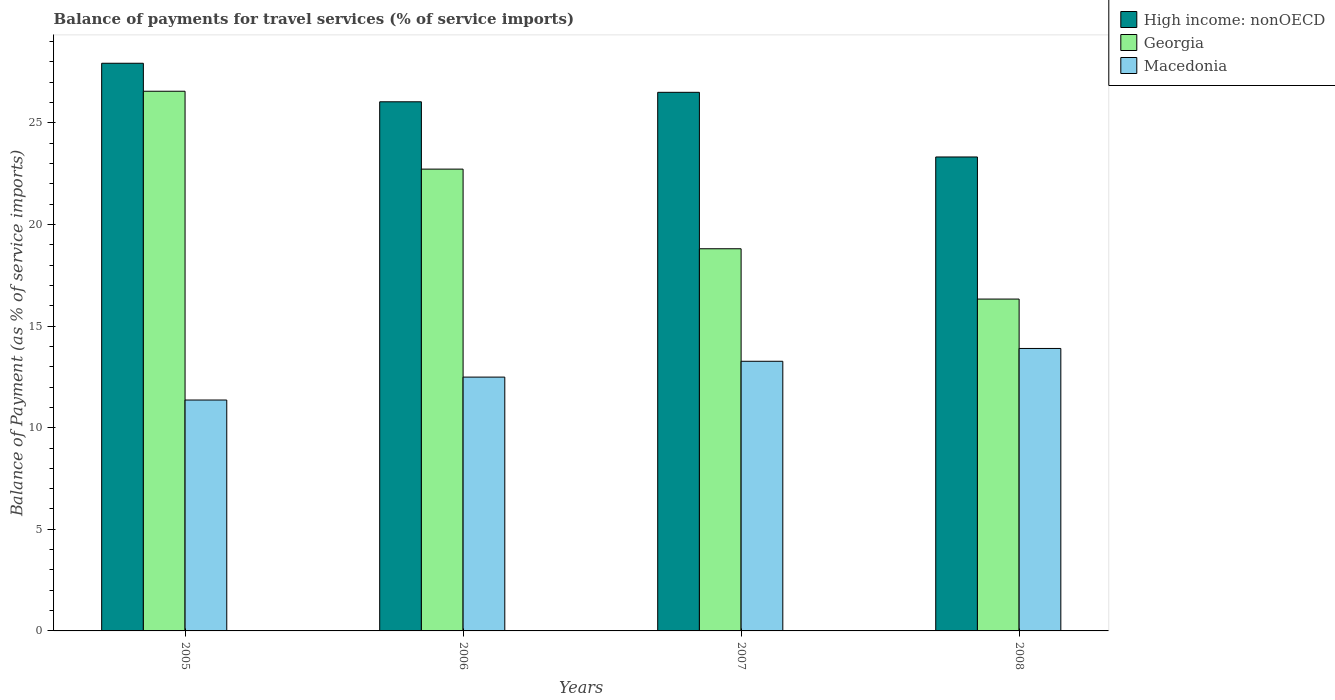How many different coloured bars are there?
Give a very brief answer. 3. How many groups of bars are there?
Give a very brief answer. 4. Are the number of bars on each tick of the X-axis equal?
Give a very brief answer. Yes. What is the label of the 3rd group of bars from the left?
Offer a terse response. 2007. In how many cases, is the number of bars for a given year not equal to the number of legend labels?
Your response must be concise. 0. What is the balance of payments for travel services in High income: nonOECD in 2007?
Offer a terse response. 26.5. Across all years, what is the maximum balance of payments for travel services in Macedonia?
Give a very brief answer. 13.9. Across all years, what is the minimum balance of payments for travel services in Macedonia?
Offer a terse response. 11.36. What is the total balance of payments for travel services in Georgia in the graph?
Your answer should be compact. 84.41. What is the difference between the balance of payments for travel services in Macedonia in 2005 and that in 2008?
Keep it short and to the point. -2.54. What is the difference between the balance of payments for travel services in Macedonia in 2007 and the balance of payments for travel services in Georgia in 2006?
Ensure brevity in your answer.  -9.46. What is the average balance of payments for travel services in High income: nonOECD per year?
Give a very brief answer. 25.95. In the year 2006, what is the difference between the balance of payments for travel services in High income: nonOECD and balance of payments for travel services in Georgia?
Make the answer very short. 3.31. What is the ratio of the balance of payments for travel services in Macedonia in 2006 to that in 2007?
Your response must be concise. 0.94. Is the balance of payments for travel services in High income: nonOECD in 2006 less than that in 2008?
Provide a short and direct response. No. What is the difference between the highest and the second highest balance of payments for travel services in Macedonia?
Your answer should be compact. 0.63. What is the difference between the highest and the lowest balance of payments for travel services in Macedonia?
Give a very brief answer. 2.54. Is the sum of the balance of payments for travel services in Georgia in 2007 and 2008 greater than the maximum balance of payments for travel services in Macedonia across all years?
Give a very brief answer. Yes. What does the 1st bar from the left in 2005 represents?
Offer a very short reply. High income: nonOECD. What does the 1st bar from the right in 2007 represents?
Offer a terse response. Macedonia. Are all the bars in the graph horizontal?
Keep it short and to the point. No. How many years are there in the graph?
Provide a short and direct response. 4. What is the difference between two consecutive major ticks on the Y-axis?
Provide a short and direct response. 5. Are the values on the major ticks of Y-axis written in scientific E-notation?
Your response must be concise. No. Does the graph contain any zero values?
Give a very brief answer. No. Where does the legend appear in the graph?
Your answer should be compact. Top right. How many legend labels are there?
Provide a succinct answer. 3. How are the legend labels stacked?
Provide a short and direct response. Vertical. What is the title of the graph?
Your answer should be compact. Balance of payments for travel services (% of service imports). What is the label or title of the X-axis?
Your answer should be compact. Years. What is the label or title of the Y-axis?
Ensure brevity in your answer.  Balance of Payment (as % of service imports). What is the Balance of Payment (as % of service imports) in High income: nonOECD in 2005?
Provide a short and direct response. 27.93. What is the Balance of Payment (as % of service imports) of Georgia in 2005?
Offer a terse response. 26.56. What is the Balance of Payment (as % of service imports) of Macedonia in 2005?
Provide a short and direct response. 11.36. What is the Balance of Payment (as % of service imports) in High income: nonOECD in 2006?
Your answer should be compact. 26.04. What is the Balance of Payment (as % of service imports) in Georgia in 2006?
Offer a very short reply. 22.72. What is the Balance of Payment (as % of service imports) of Macedonia in 2006?
Keep it short and to the point. 12.49. What is the Balance of Payment (as % of service imports) in High income: nonOECD in 2007?
Provide a short and direct response. 26.5. What is the Balance of Payment (as % of service imports) in Georgia in 2007?
Your answer should be compact. 18.8. What is the Balance of Payment (as % of service imports) in Macedonia in 2007?
Provide a short and direct response. 13.27. What is the Balance of Payment (as % of service imports) of High income: nonOECD in 2008?
Make the answer very short. 23.32. What is the Balance of Payment (as % of service imports) in Georgia in 2008?
Keep it short and to the point. 16.33. What is the Balance of Payment (as % of service imports) in Macedonia in 2008?
Your answer should be compact. 13.9. Across all years, what is the maximum Balance of Payment (as % of service imports) of High income: nonOECD?
Give a very brief answer. 27.93. Across all years, what is the maximum Balance of Payment (as % of service imports) of Georgia?
Provide a succinct answer. 26.56. Across all years, what is the maximum Balance of Payment (as % of service imports) in Macedonia?
Give a very brief answer. 13.9. Across all years, what is the minimum Balance of Payment (as % of service imports) of High income: nonOECD?
Your answer should be compact. 23.32. Across all years, what is the minimum Balance of Payment (as % of service imports) of Georgia?
Keep it short and to the point. 16.33. Across all years, what is the minimum Balance of Payment (as % of service imports) in Macedonia?
Provide a succinct answer. 11.36. What is the total Balance of Payment (as % of service imports) in High income: nonOECD in the graph?
Provide a short and direct response. 103.79. What is the total Balance of Payment (as % of service imports) of Georgia in the graph?
Your response must be concise. 84.41. What is the total Balance of Payment (as % of service imports) of Macedonia in the graph?
Your answer should be compact. 51.02. What is the difference between the Balance of Payment (as % of service imports) in High income: nonOECD in 2005 and that in 2006?
Provide a succinct answer. 1.9. What is the difference between the Balance of Payment (as % of service imports) in Georgia in 2005 and that in 2006?
Give a very brief answer. 3.83. What is the difference between the Balance of Payment (as % of service imports) of Macedonia in 2005 and that in 2006?
Ensure brevity in your answer.  -1.13. What is the difference between the Balance of Payment (as % of service imports) in High income: nonOECD in 2005 and that in 2007?
Your response must be concise. 1.43. What is the difference between the Balance of Payment (as % of service imports) in Georgia in 2005 and that in 2007?
Ensure brevity in your answer.  7.75. What is the difference between the Balance of Payment (as % of service imports) of Macedonia in 2005 and that in 2007?
Your answer should be compact. -1.91. What is the difference between the Balance of Payment (as % of service imports) of High income: nonOECD in 2005 and that in 2008?
Keep it short and to the point. 4.61. What is the difference between the Balance of Payment (as % of service imports) in Georgia in 2005 and that in 2008?
Keep it short and to the point. 10.23. What is the difference between the Balance of Payment (as % of service imports) in Macedonia in 2005 and that in 2008?
Ensure brevity in your answer.  -2.54. What is the difference between the Balance of Payment (as % of service imports) in High income: nonOECD in 2006 and that in 2007?
Make the answer very short. -0.47. What is the difference between the Balance of Payment (as % of service imports) of Georgia in 2006 and that in 2007?
Your answer should be very brief. 3.92. What is the difference between the Balance of Payment (as % of service imports) of Macedonia in 2006 and that in 2007?
Your response must be concise. -0.78. What is the difference between the Balance of Payment (as % of service imports) of High income: nonOECD in 2006 and that in 2008?
Provide a short and direct response. 2.72. What is the difference between the Balance of Payment (as % of service imports) of Georgia in 2006 and that in 2008?
Make the answer very short. 6.4. What is the difference between the Balance of Payment (as % of service imports) of Macedonia in 2006 and that in 2008?
Your response must be concise. -1.41. What is the difference between the Balance of Payment (as % of service imports) of High income: nonOECD in 2007 and that in 2008?
Keep it short and to the point. 3.18. What is the difference between the Balance of Payment (as % of service imports) of Georgia in 2007 and that in 2008?
Provide a succinct answer. 2.48. What is the difference between the Balance of Payment (as % of service imports) in Macedonia in 2007 and that in 2008?
Make the answer very short. -0.63. What is the difference between the Balance of Payment (as % of service imports) of High income: nonOECD in 2005 and the Balance of Payment (as % of service imports) of Georgia in 2006?
Make the answer very short. 5.21. What is the difference between the Balance of Payment (as % of service imports) of High income: nonOECD in 2005 and the Balance of Payment (as % of service imports) of Macedonia in 2006?
Give a very brief answer. 15.44. What is the difference between the Balance of Payment (as % of service imports) in Georgia in 2005 and the Balance of Payment (as % of service imports) in Macedonia in 2006?
Provide a short and direct response. 14.07. What is the difference between the Balance of Payment (as % of service imports) in High income: nonOECD in 2005 and the Balance of Payment (as % of service imports) in Georgia in 2007?
Ensure brevity in your answer.  9.13. What is the difference between the Balance of Payment (as % of service imports) in High income: nonOECD in 2005 and the Balance of Payment (as % of service imports) in Macedonia in 2007?
Ensure brevity in your answer.  14.66. What is the difference between the Balance of Payment (as % of service imports) in Georgia in 2005 and the Balance of Payment (as % of service imports) in Macedonia in 2007?
Offer a very short reply. 13.29. What is the difference between the Balance of Payment (as % of service imports) in High income: nonOECD in 2005 and the Balance of Payment (as % of service imports) in Georgia in 2008?
Offer a very short reply. 11.6. What is the difference between the Balance of Payment (as % of service imports) of High income: nonOECD in 2005 and the Balance of Payment (as % of service imports) of Macedonia in 2008?
Offer a very short reply. 14.03. What is the difference between the Balance of Payment (as % of service imports) in Georgia in 2005 and the Balance of Payment (as % of service imports) in Macedonia in 2008?
Give a very brief answer. 12.66. What is the difference between the Balance of Payment (as % of service imports) of High income: nonOECD in 2006 and the Balance of Payment (as % of service imports) of Georgia in 2007?
Your answer should be compact. 7.23. What is the difference between the Balance of Payment (as % of service imports) of High income: nonOECD in 2006 and the Balance of Payment (as % of service imports) of Macedonia in 2007?
Provide a succinct answer. 12.77. What is the difference between the Balance of Payment (as % of service imports) of Georgia in 2006 and the Balance of Payment (as % of service imports) of Macedonia in 2007?
Provide a short and direct response. 9.46. What is the difference between the Balance of Payment (as % of service imports) in High income: nonOECD in 2006 and the Balance of Payment (as % of service imports) in Georgia in 2008?
Your answer should be compact. 9.71. What is the difference between the Balance of Payment (as % of service imports) in High income: nonOECD in 2006 and the Balance of Payment (as % of service imports) in Macedonia in 2008?
Offer a very short reply. 12.14. What is the difference between the Balance of Payment (as % of service imports) in Georgia in 2006 and the Balance of Payment (as % of service imports) in Macedonia in 2008?
Keep it short and to the point. 8.82. What is the difference between the Balance of Payment (as % of service imports) in High income: nonOECD in 2007 and the Balance of Payment (as % of service imports) in Georgia in 2008?
Make the answer very short. 10.17. What is the difference between the Balance of Payment (as % of service imports) in High income: nonOECD in 2007 and the Balance of Payment (as % of service imports) in Macedonia in 2008?
Give a very brief answer. 12.6. What is the difference between the Balance of Payment (as % of service imports) of Georgia in 2007 and the Balance of Payment (as % of service imports) of Macedonia in 2008?
Offer a very short reply. 4.91. What is the average Balance of Payment (as % of service imports) of High income: nonOECD per year?
Make the answer very short. 25.95. What is the average Balance of Payment (as % of service imports) of Georgia per year?
Provide a short and direct response. 21.1. What is the average Balance of Payment (as % of service imports) of Macedonia per year?
Keep it short and to the point. 12.75. In the year 2005, what is the difference between the Balance of Payment (as % of service imports) of High income: nonOECD and Balance of Payment (as % of service imports) of Georgia?
Give a very brief answer. 1.38. In the year 2005, what is the difference between the Balance of Payment (as % of service imports) of High income: nonOECD and Balance of Payment (as % of service imports) of Macedonia?
Keep it short and to the point. 16.57. In the year 2005, what is the difference between the Balance of Payment (as % of service imports) in Georgia and Balance of Payment (as % of service imports) in Macedonia?
Provide a short and direct response. 15.19. In the year 2006, what is the difference between the Balance of Payment (as % of service imports) of High income: nonOECD and Balance of Payment (as % of service imports) of Georgia?
Give a very brief answer. 3.31. In the year 2006, what is the difference between the Balance of Payment (as % of service imports) in High income: nonOECD and Balance of Payment (as % of service imports) in Macedonia?
Offer a terse response. 13.55. In the year 2006, what is the difference between the Balance of Payment (as % of service imports) in Georgia and Balance of Payment (as % of service imports) in Macedonia?
Keep it short and to the point. 10.23. In the year 2007, what is the difference between the Balance of Payment (as % of service imports) in High income: nonOECD and Balance of Payment (as % of service imports) in Georgia?
Provide a succinct answer. 7.7. In the year 2007, what is the difference between the Balance of Payment (as % of service imports) of High income: nonOECD and Balance of Payment (as % of service imports) of Macedonia?
Make the answer very short. 13.23. In the year 2007, what is the difference between the Balance of Payment (as % of service imports) of Georgia and Balance of Payment (as % of service imports) of Macedonia?
Your answer should be compact. 5.54. In the year 2008, what is the difference between the Balance of Payment (as % of service imports) of High income: nonOECD and Balance of Payment (as % of service imports) of Georgia?
Offer a terse response. 6.99. In the year 2008, what is the difference between the Balance of Payment (as % of service imports) of High income: nonOECD and Balance of Payment (as % of service imports) of Macedonia?
Your answer should be very brief. 9.42. In the year 2008, what is the difference between the Balance of Payment (as % of service imports) in Georgia and Balance of Payment (as % of service imports) in Macedonia?
Provide a succinct answer. 2.43. What is the ratio of the Balance of Payment (as % of service imports) in High income: nonOECD in 2005 to that in 2006?
Your answer should be compact. 1.07. What is the ratio of the Balance of Payment (as % of service imports) of Georgia in 2005 to that in 2006?
Provide a short and direct response. 1.17. What is the ratio of the Balance of Payment (as % of service imports) of Macedonia in 2005 to that in 2006?
Offer a terse response. 0.91. What is the ratio of the Balance of Payment (as % of service imports) in High income: nonOECD in 2005 to that in 2007?
Your answer should be compact. 1.05. What is the ratio of the Balance of Payment (as % of service imports) in Georgia in 2005 to that in 2007?
Provide a succinct answer. 1.41. What is the ratio of the Balance of Payment (as % of service imports) of Macedonia in 2005 to that in 2007?
Your response must be concise. 0.86. What is the ratio of the Balance of Payment (as % of service imports) of High income: nonOECD in 2005 to that in 2008?
Your answer should be compact. 1.2. What is the ratio of the Balance of Payment (as % of service imports) in Georgia in 2005 to that in 2008?
Your response must be concise. 1.63. What is the ratio of the Balance of Payment (as % of service imports) of Macedonia in 2005 to that in 2008?
Your response must be concise. 0.82. What is the ratio of the Balance of Payment (as % of service imports) in High income: nonOECD in 2006 to that in 2007?
Provide a short and direct response. 0.98. What is the ratio of the Balance of Payment (as % of service imports) of Georgia in 2006 to that in 2007?
Ensure brevity in your answer.  1.21. What is the ratio of the Balance of Payment (as % of service imports) in Macedonia in 2006 to that in 2007?
Offer a terse response. 0.94. What is the ratio of the Balance of Payment (as % of service imports) of High income: nonOECD in 2006 to that in 2008?
Offer a very short reply. 1.12. What is the ratio of the Balance of Payment (as % of service imports) of Georgia in 2006 to that in 2008?
Offer a terse response. 1.39. What is the ratio of the Balance of Payment (as % of service imports) in Macedonia in 2006 to that in 2008?
Offer a terse response. 0.9. What is the ratio of the Balance of Payment (as % of service imports) of High income: nonOECD in 2007 to that in 2008?
Make the answer very short. 1.14. What is the ratio of the Balance of Payment (as % of service imports) in Georgia in 2007 to that in 2008?
Keep it short and to the point. 1.15. What is the ratio of the Balance of Payment (as % of service imports) in Macedonia in 2007 to that in 2008?
Offer a terse response. 0.95. What is the difference between the highest and the second highest Balance of Payment (as % of service imports) in High income: nonOECD?
Your answer should be very brief. 1.43. What is the difference between the highest and the second highest Balance of Payment (as % of service imports) of Georgia?
Give a very brief answer. 3.83. What is the difference between the highest and the second highest Balance of Payment (as % of service imports) of Macedonia?
Give a very brief answer. 0.63. What is the difference between the highest and the lowest Balance of Payment (as % of service imports) in High income: nonOECD?
Offer a very short reply. 4.61. What is the difference between the highest and the lowest Balance of Payment (as % of service imports) in Georgia?
Your answer should be compact. 10.23. What is the difference between the highest and the lowest Balance of Payment (as % of service imports) of Macedonia?
Your answer should be very brief. 2.54. 